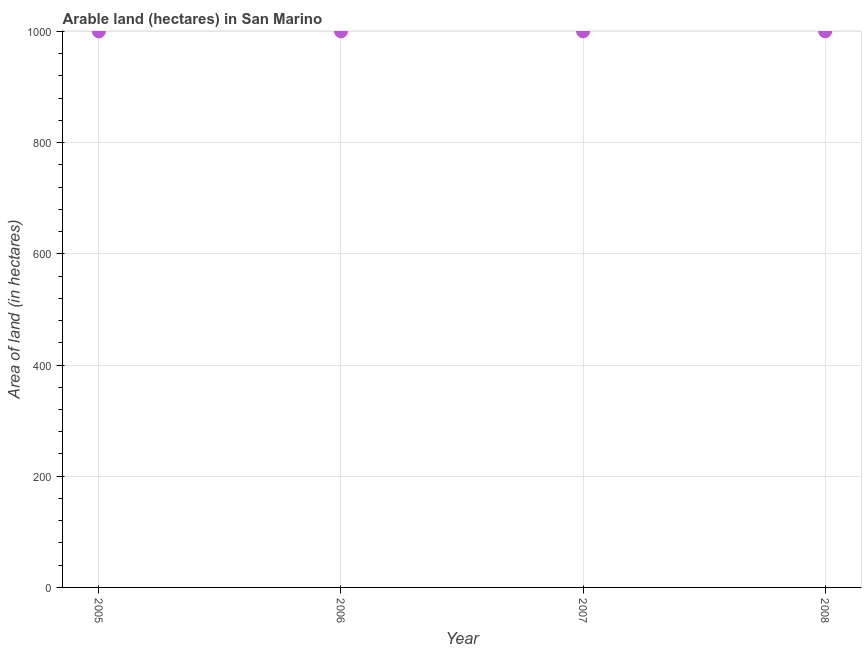What is the area of land in 2005?
Offer a terse response. 1000. Across all years, what is the maximum area of land?
Your answer should be compact. 1000. Across all years, what is the minimum area of land?
Offer a very short reply. 1000. In which year was the area of land maximum?
Make the answer very short. 2005. In which year was the area of land minimum?
Keep it short and to the point. 2005. What is the sum of the area of land?
Give a very brief answer. 4000. What is the average area of land per year?
Ensure brevity in your answer.  1000. In how many years, is the area of land greater than 680 hectares?
Ensure brevity in your answer.  4. Do a majority of the years between 2005 and 2007 (inclusive) have area of land greater than 360 hectares?
Your response must be concise. Yes. What is the ratio of the area of land in 2007 to that in 2008?
Ensure brevity in your answer.  1. Is the area of land in 2007 less than that in 2008?
Give a very brief answer. No. Is the difference between the area of land in 2006 and 2008 greater than the difference between any two years?
Provide a succinct answer. Yes. What is the difference between the highest and the second highest area of land?
Provide a succinct answer. 0. Is the sum of the area of land in 2005 and 2006 greater than the maximum area of land across all years?
Provide a succinct answer. Yes. How many years are there in the graph?
Offer a very short reply. 4. Are the values on the major ticks of Y-axis written in scientific E-notation?
Offer a very short reply. No. What is the title of the graph?
Provide a short and direct response. Arable land (hectares) in San Marino. What is the label or title of the Y-axis?
Offer a terse response. Area of land (in hectares). What is the difference between the Area of land (in hectares) in 2005 and 2006?
Give a very brief answer. 0. What is the difference between the Area of land (in hectares) in 2005 and 2007?
Offer a terse response. 0. What is the difference between the Area of land (in hectares) in 2006 and 2007?
Your answer should be compact. 0. What is the difference between the Area of land (in hectares) in 2006 and 2008?
Give a very brief answer. 0. What is the difference between the Area of land (in hectares) in 2007 and 2008?
Your response must be concise. 0. What is the ratio of the Area of land (in hectares) in 2006 to that in 2007?
Provide a succinct answer. 1. What is the ratio of the Area of land (in hectares) in 2006 to that in 2008?
Your answer should be very brief. 1. What is the ratio of the Area of land (in hectares) in 2007 to that in 2008?
Your response must be concise. 1. 